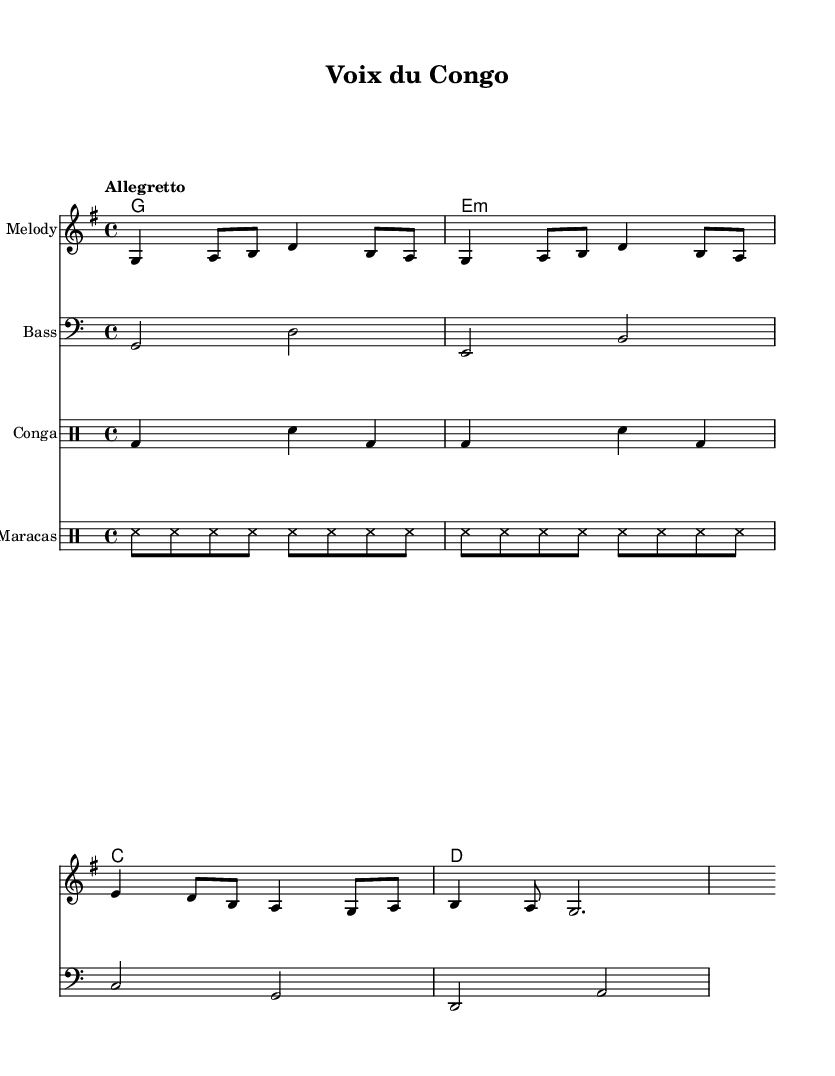What is the key signature of this music? The key signature is G major, which has one sharp (F#). This can be identified by looking at the key signature at the beginning of the staff, which shows one sharp symbol.
Answer: G major What is the time signature of this music? The time signature is 4/4, which is indicated at the beginning of the score where it shows the fraction. This means there are four beats in each measure.
Answer: 4/4 What is the tempo marking of this music? The tempo marking is "Allegretto," which is indicated above the staff. Allegretto typically means moderately fast, giving an idea of the desired speed.
Answer: Allegretto How many measures are in the melody? There are eight measures in the melody section. Each measure is separated by vertical lines in the sheet music, and by counting these lines, you can determine the number of measures present.
Answer: Eight Which instruments are used in this piece? The piece features melody, bass, conga, and maracas. By looking at the score, the different staves represent each instrument respectively, indicating their inclusion.
Answer: Melody, bass, conga, maracas What lyrical theme is presented in the piece? The lyrical theme presents cultural unity and roots, as seen in the lyrics that celebrate the voices from Congo and America. Analyzing the lyrics highlights the theme of connecting diverse cultural backgrounds.
Answer: Cultural unity 